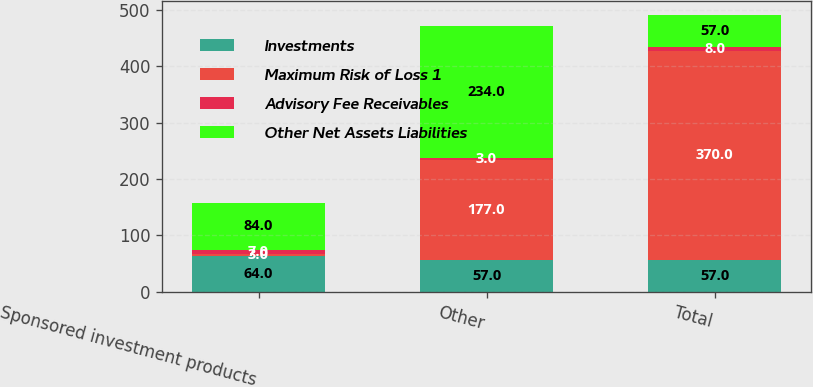<chart> <loc_0><loc_0><loc_500><loc_500><stacked_bar_chart><ecel><fcel>Sponsored investment products<fcel>Other<fcel>Total<nl><fcel>Investments<fcel>64<fcel>57<fcel>57<nl><fcel>Maximum Risk of Loss 1<fcel>3<fcel>177<fcel>370<nl><fcel>Advisory Fee Receivables<fcel>7<fcel>3<fcel>8<nl><fcel>Other Net Assets Liabilities<fcel>84<fcel>234<fcel>57<nl></chart> 